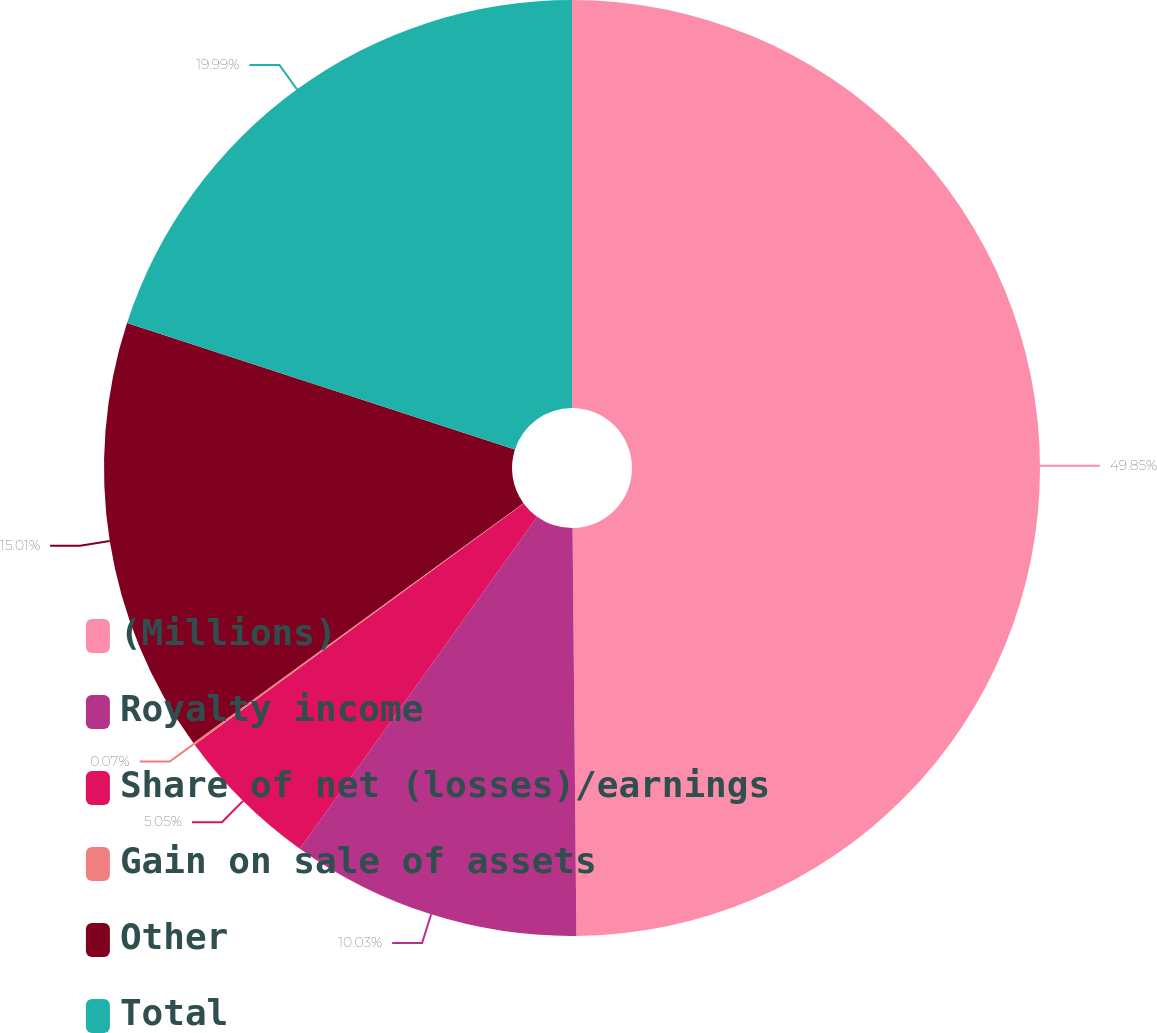<chart> <loc_0><loc_0><loc_500><loc_500><pie_chart><fcel>(Millions)<fcel>Royalty income<fcel>Share of net (losses)/earnings<fcel>Gain on sale of assets<fcel>Other<fcel>Total<nl><fcel>49.85%<fcel>10.03%<fcel>5.05%<fcel>0.07%<fcel>15.01%<fcel>19.99%<nl></chart> 